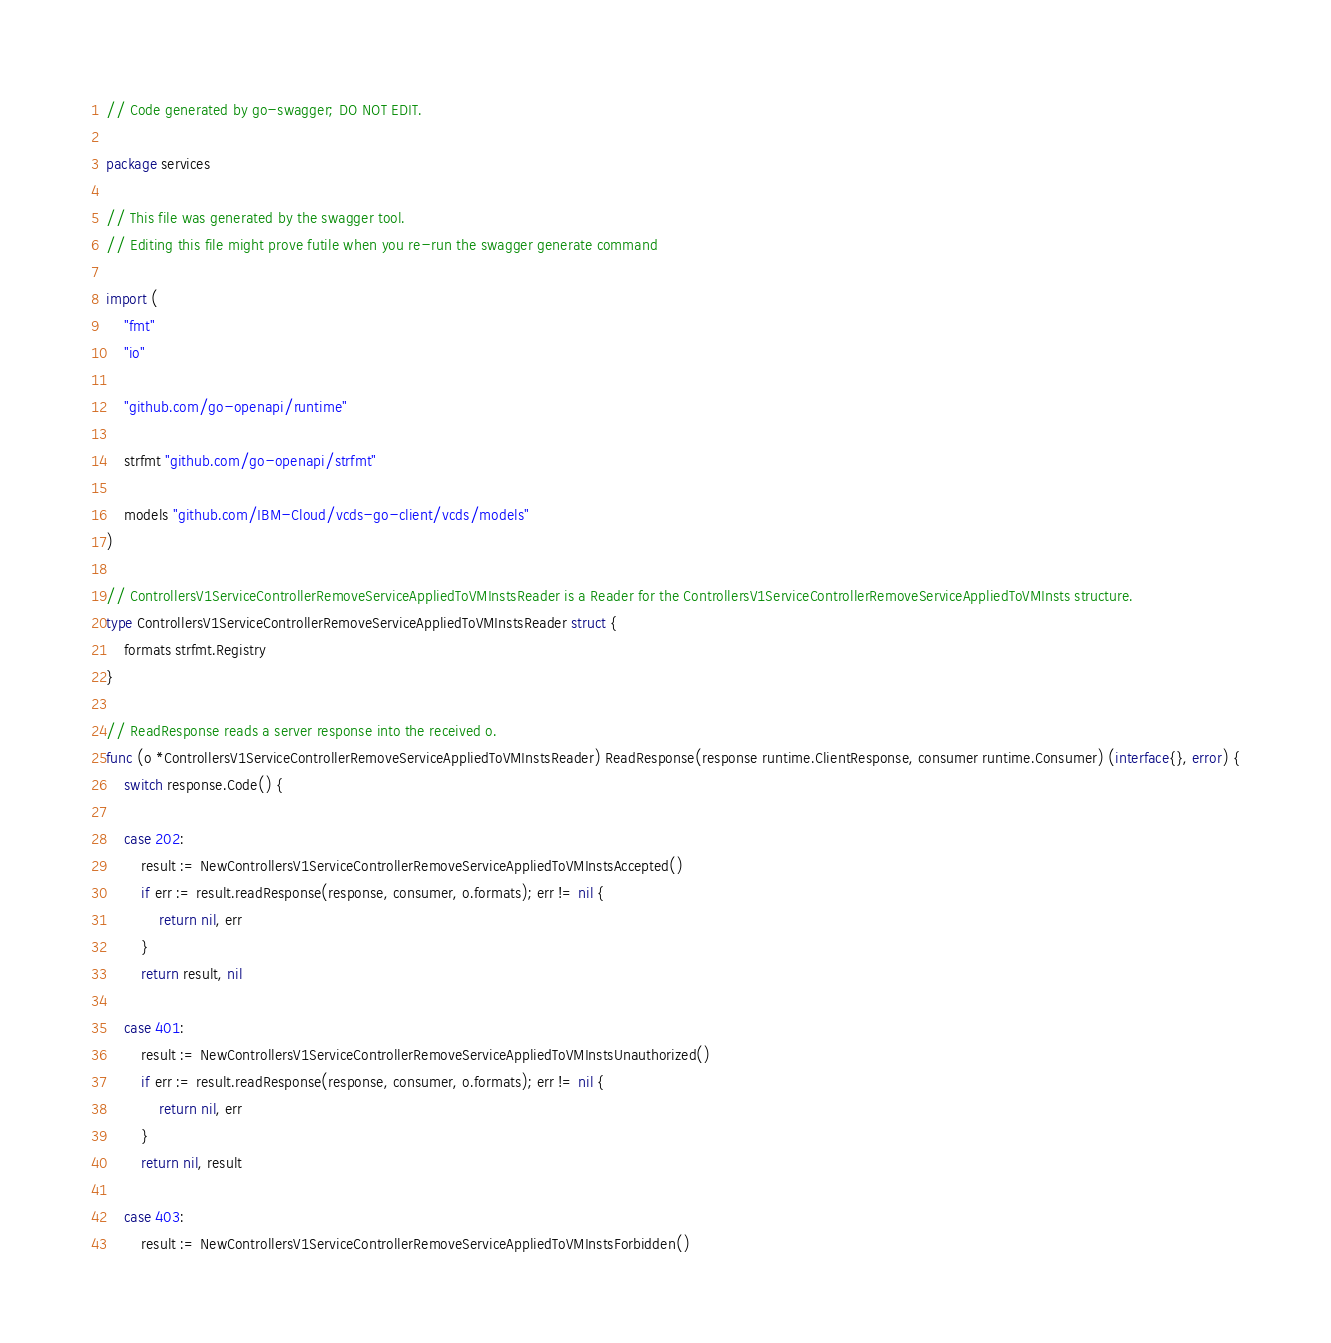Convert code to text. <code><loc_0><loc_0><loc_500><loc_500><_Go_>// Code generated by go-swagger; DO NOT EDIT.

package services

// This file was generated by the swagger tool.
// Editing this file might prove futile when you re-run the swagger generate command

import (
	"fmt"
	"io"

	"github.com/go-openapi/runtime"

	strfmt "github.com/go-openapi/strfmt"

	models "github.com/IBM-Cloud/vcds-go-client/vcds/models"
)

// ControllersV1ServiceControllerRemoveServiceAppliedToVMInstsReader is a Reader for the ControllersV1ServiceControllerRemoveServiceAppliedToVMInsts structure.
type ControllersV1ServiceControllerRemoveServiceAppliedToVMInstsReader struct {
	formats strfmt.Registry
}

// ReadResponse reads a server response into the received o.
func (o *ControllersV1ServiceControllerRemoveServiceAppliedToVMInstsReader) ReadResponse(response runtime.ClientResponse, consumer runtime.Consumer) (interface{}, error) {
	switch response.Code() {

	case 202:
		result := NewControllersV1ServiceControllerRemoveServiceAppliedToVMInstsAccepted()
		if err := result.readResponse(response, consumer, o.formats); err != nil {
			return nil, err
		}
		return result, nil

	case 401:
		result := NewControllersV1ServiceControllerRemoveServiceAppliedToVMInstsUnauthorized()
		if err := result.readResponse(response, consumer, o.formats); err != nil {
			return nil, err
		}
		return nil, result

	case 403:
		result := NewControllersV1ServiceControllerRemoveServiceAppliedToVMInstsForbidden()</code> 